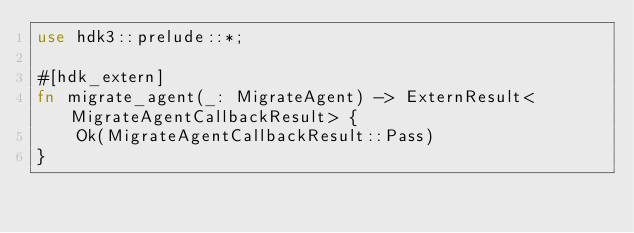<code> <loc_0><loc_0><loc_500><loc_500><_Rust_>use hdk3::prelude::*;

#[hdk_extern]
fn migrate_agent(_: MigrateAgent) -> ExternResult<MigrateAgentCallbackResult> {
    Ok(MigrateAgentCallbackResult::Pass)
}
</code> 